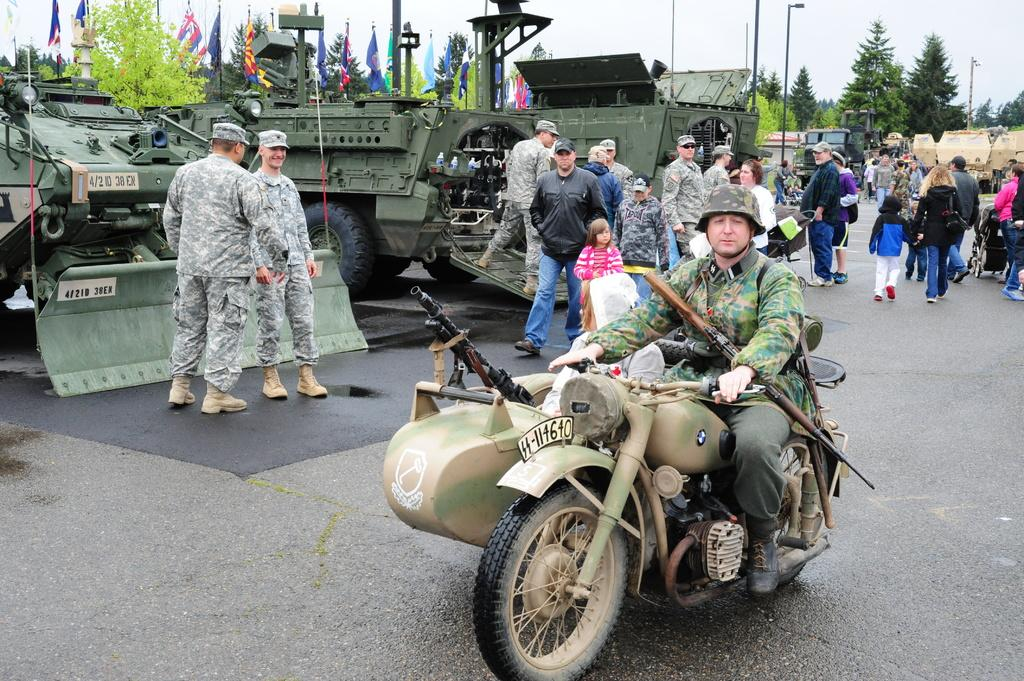What is the man in the image doing? The man is riding a bike in the image. What is the man wearing while riding the bike? The man is wearing a helmet in the image. Where is the bike located? The bike is on the road in the image. What can be seen in the background of the image? In the background of the image, there are many people, army tankers, flags, trees, and poles on the road. What type of branch is the man using to steer the bike in the image? There is no branch present in the image; the man is using handlebars to steer the bike. 